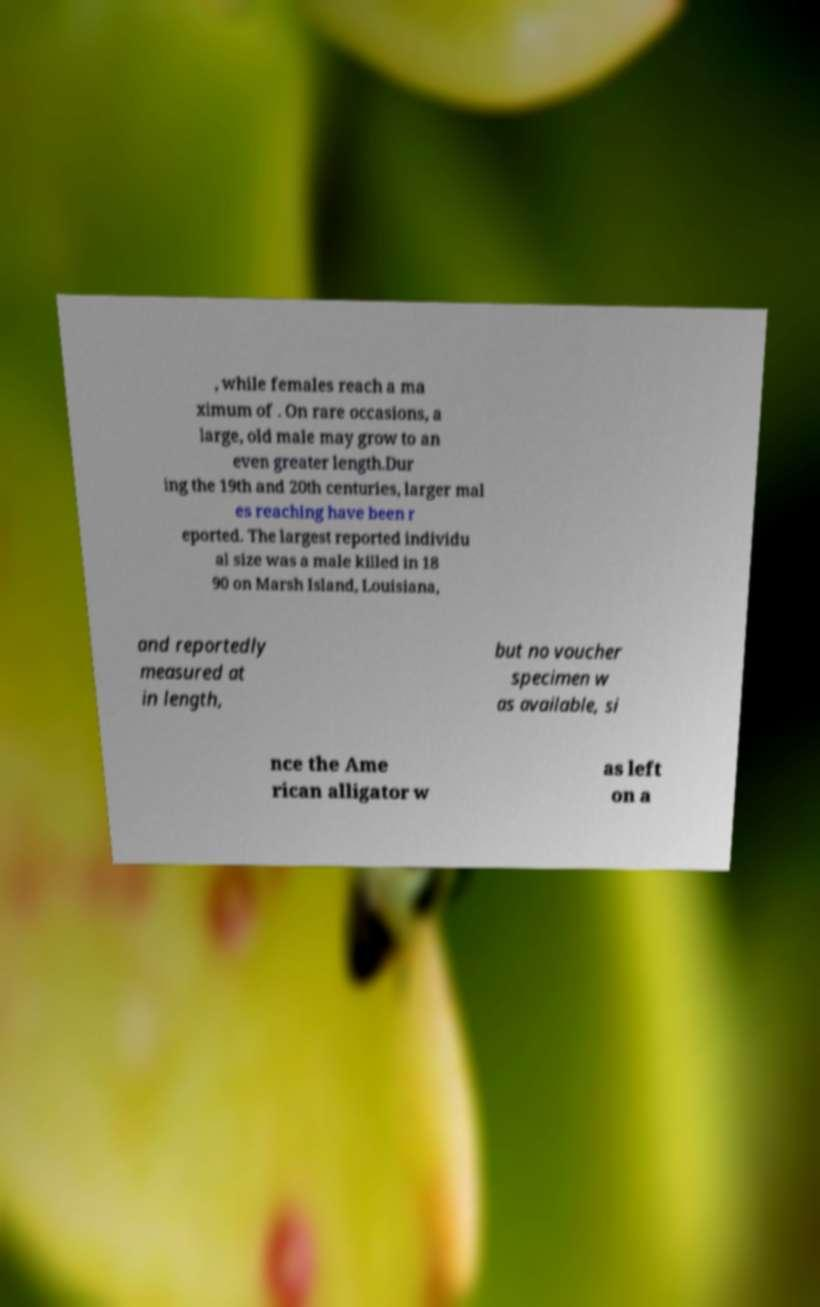There's text embedded in this image that I need extracted. Can you transcribe it verbatim? , while females reach a ma ximum of . On rare occasions, a large, old male may grow to an even greater length.Dur ing the 19th and 20th centuries, larger mal es reaching have been r eported. The largest reported individu al size was a male killed in 18 90 on Marsh Island, Louisiana, and reportedly measured at in length, but no voucher specimen w as available, si nce the Ame rican alligator w as left on a 